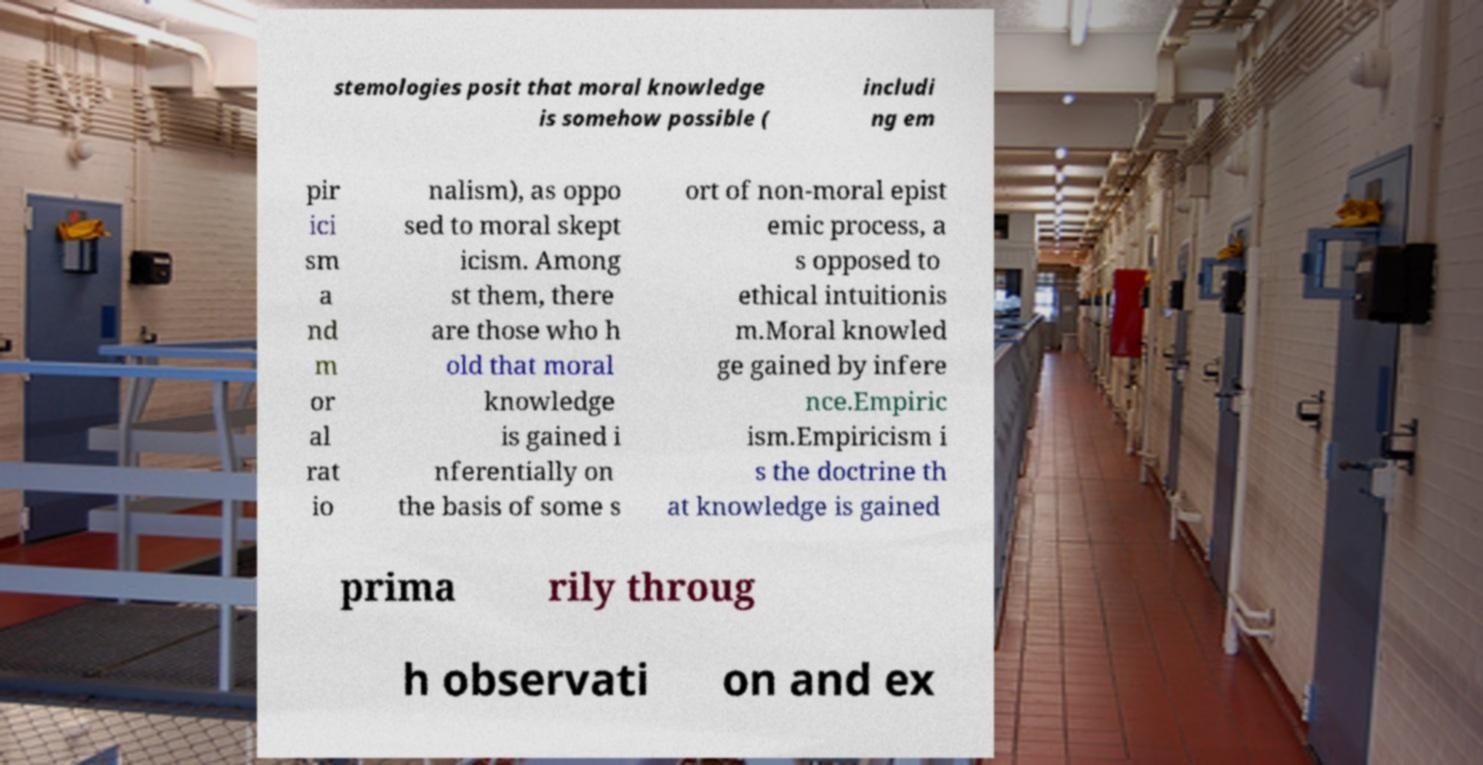Can you read and provide the text displayed in the image?This photo seems to have some interesting text. Can you extract and type it out for me? stemologies posit that moral knowledge is somehow possible ( includi ng em pir ici sm a nd m or al rat io nalism), as oppo sed to moral skept icism. Among st them, there are those who h old that moral knowledge is gained i nferentially on the basis of some s ort of non-moral epist emic process, a s opposed to ethical intuitionis m.Moral knowled ge gained by infere nce.Empiric ism.Empiricism i s the doctrine th at knowledge is gained prima rily throug h observati on and ex 